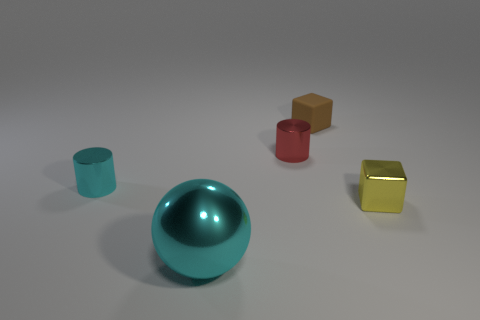How does the lighting affect the appearance of the objects? The lighting in the image creates soft shadows and subtle reflections on the objects. This accentuates their three-dimensional forms and enhances the visual texture of the materials, particularly the metallic surfaces that reflect the light more prominently. 